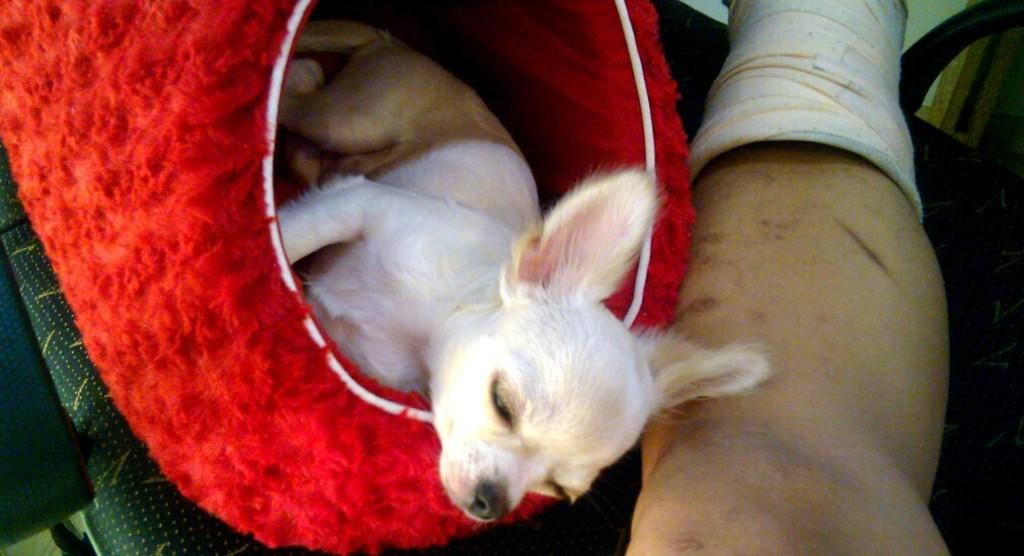What animal is present in the image? There is a dog in the image. How is the dog positioned in the image? The dog appears to be in a red-colored bag. What part of a person can be seen in the image? There is a person's leg visible in the image. What is the color of the table the leg is resting on? The table the leg is resting on is black in color. What color is the cloth on the left side of the image? There is a green-colored cloth on the left side of the image. What type of pencil is being used to draw on the road in the image? There is no pencil or road present in the image; it features a dog in a red-colored bag and a person's leg resting on a black table. What degree of education does the person in the image have? There is no information about the person's education in the image. 